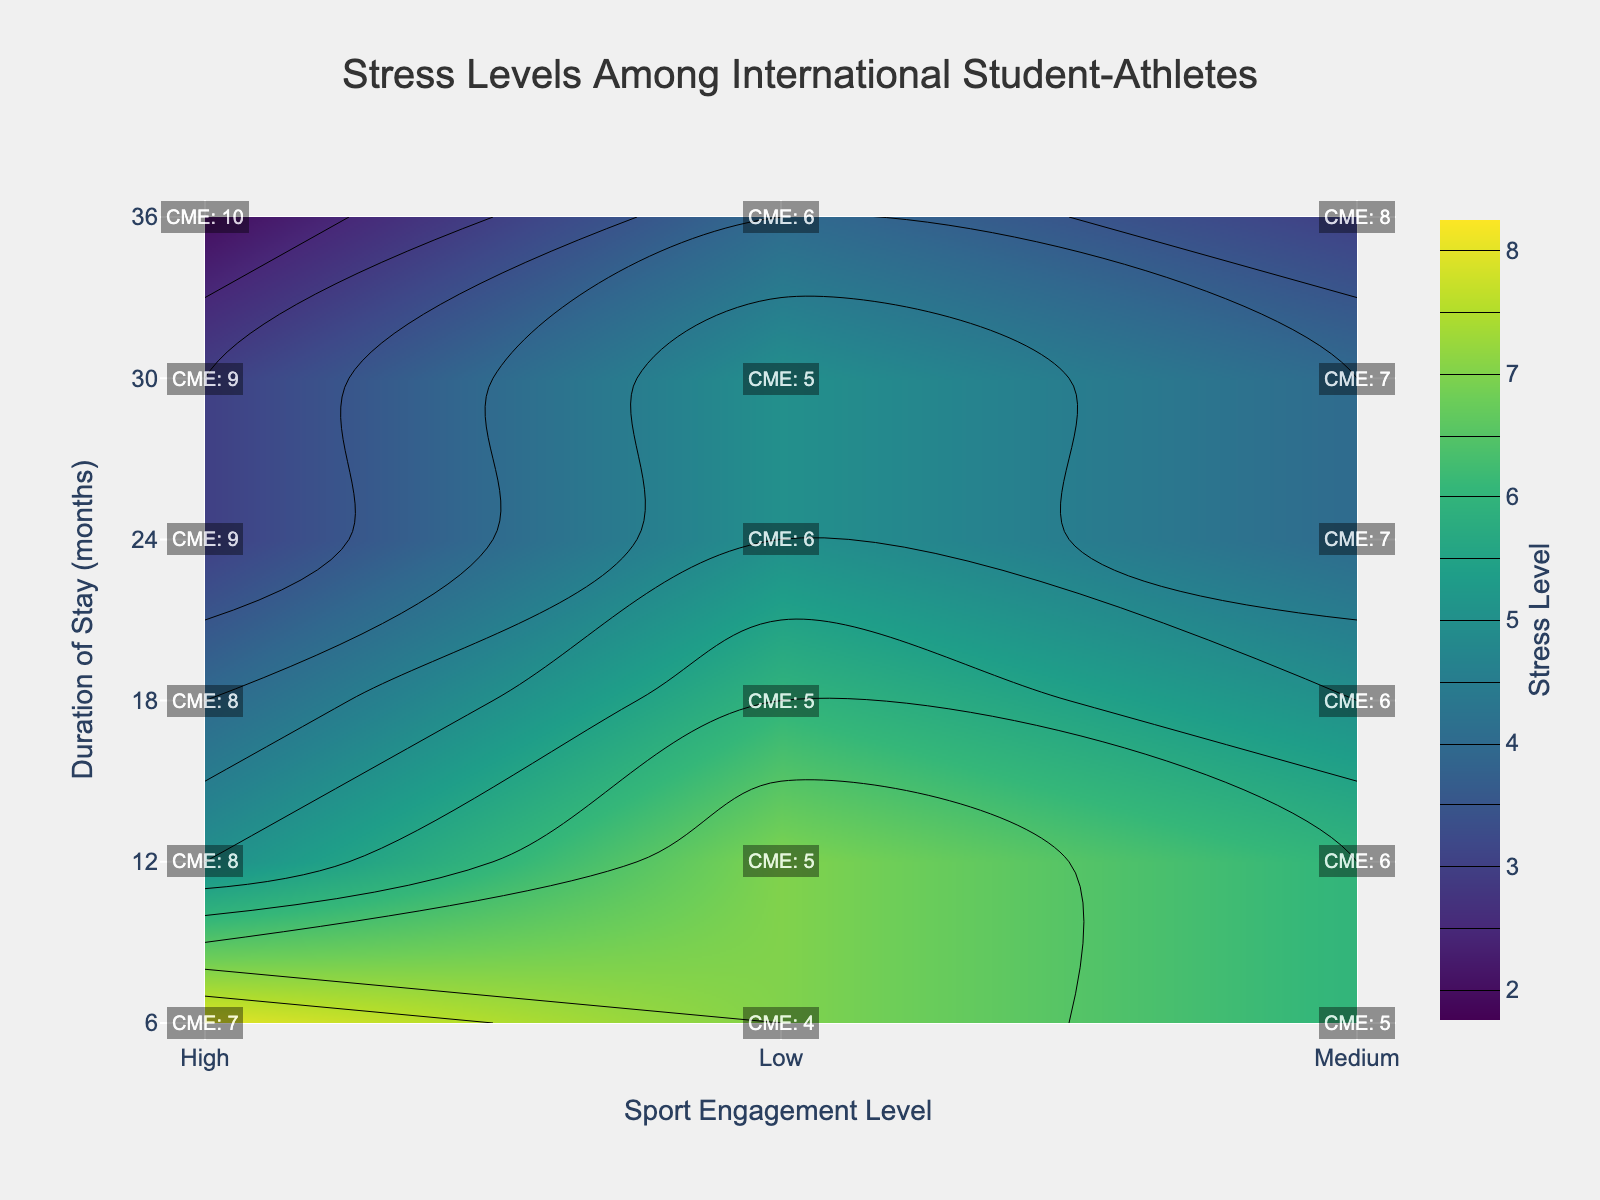What is the lowest stress level observed? The lowest stress level value on the color map can be found at the darkest color shade. By looking at the color bar and comparing the colors, the lowest stress level observed is 2 at 36 months of stay with High engagement in sports.
Answer: 2 What is the average stress level for students staying for 18 months? To calculate the average stress level for 18 months, identify the stress levels for Low, Medium, and High sport engagement at this duration; they are 6, 5, and 4 respectively. Calculate the average: (6+5+4)/3.
Answer: 5 Which sport engagement level corresponds to the highest stress level for students staying for 6 months? Observing the 6 months row, the stress levels are given for High, Medium, and Low engagements. The highest of them is observed at High engagement with a stress level of 8.
Answer: High Does higher sport engagement consistently correlate with lower stress levels at all durations? Review the trend in stress levels by comparing High, Medium, and Low engagement stresses at each duration. Generally, as engagement increases (Low -> Medium -> High), stress decreases. This trend is consistent across all durations.
Answer: Yes What coping mechanism effectiveness (CME) corresponds to a stress level of 3? Identify stress levels equal to 3 on the plot. Checking the annotations, a stress level of 3 is found at 24 and 30 months of stay with High sport engagement. The CME values for both points are 9.
Answer: 9 How does the coping mechanism effectiveness change for Medium sport engagement as the duration of stay increases? Extract CME values for Medium engagement at each time point: 5 (6 months), 6 (12 months), 6 (18 months), 7 (24 months), 7 (30 months), 8 (36 months). The CME gradually increases over time.
Answer: Increases Is the highest stress level found in the 12-month duration? Check the stress levels at 12 months for all sport engagement levels. The highest is 7 (Low engagement), which is not the maximum stress level on the overall plot (which is 8).
Answer: No What is the change in stress levels between 6 months and 36 months for Medium sport engagement? Compare the stress levels at these time points: 6 (6 months) and 3 (36 months). The change is 6 - 3.
Answer: 3 At what duration and sport engagement the highest coping mechanism effectiveness is observed? Find the highest CME value from the annotations. The maximum CME is 10, seen at 36 months with High sport engagement.
Answer: 36 months, High How does the stress level vary for Low sport engagement from 6 months to 36 months? List the stress levels for Low engagement for each duration: 7 (6 months), 7 (12 months), 6 (18 months), 5 (24 months), 5 (30 months), 4 (36 months). The stress level decreases over time.
Answer: Decreases 